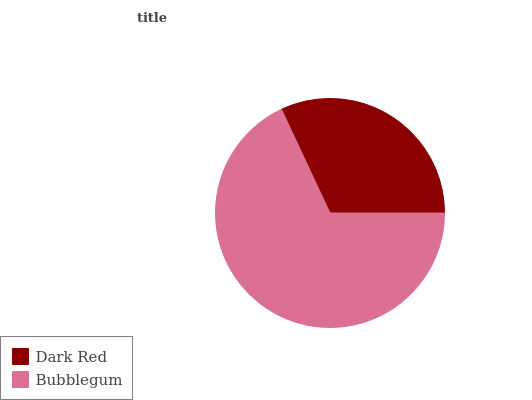Is Dark Red the minimum?
Answer yes or no. Yes. Is Bubblegum the maximum?
Answer yes or no. Yes. Is Bubblegum the minimum?
Answer yes or no. No. Is Bubblegum greater than Dark Red?
Answer yes or no. Yes. Is Dark Red less than Bubblegum?
Answer yes or no. Yes. Is Dark Red greater than Bubblegum?
Answer yes or no. No. Is Bubblegum less than Dark Red?
Answer yes or no. No. Is Bubblegum the high median?
Answer yes or no. Yes. Is Dark Red the low median?
Answer yes or no. Yes. Is Dark Red the high median?
Answer yes or no. No. Is Bubblegum the low median?
Answer yes or no. No. 